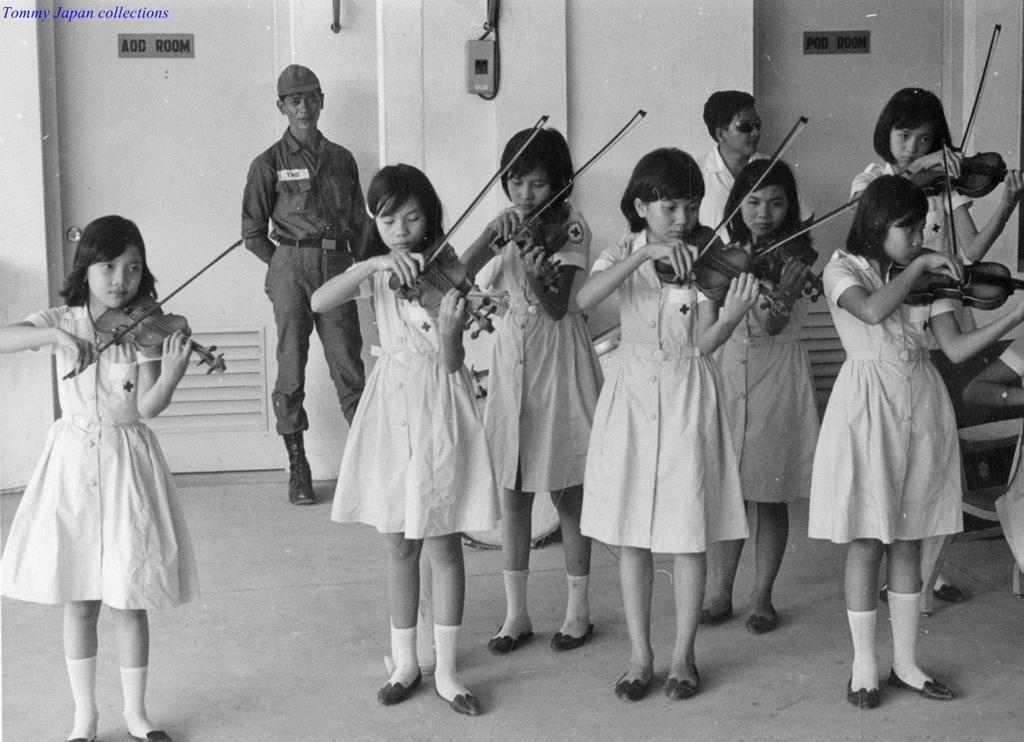Can you describe this image briefly? In this image, we can see people playing guitars. In the background, there is a person wearing uniform and a cap and we can see a chair and there is a person and we can see some boards on the wall and there is some text. 